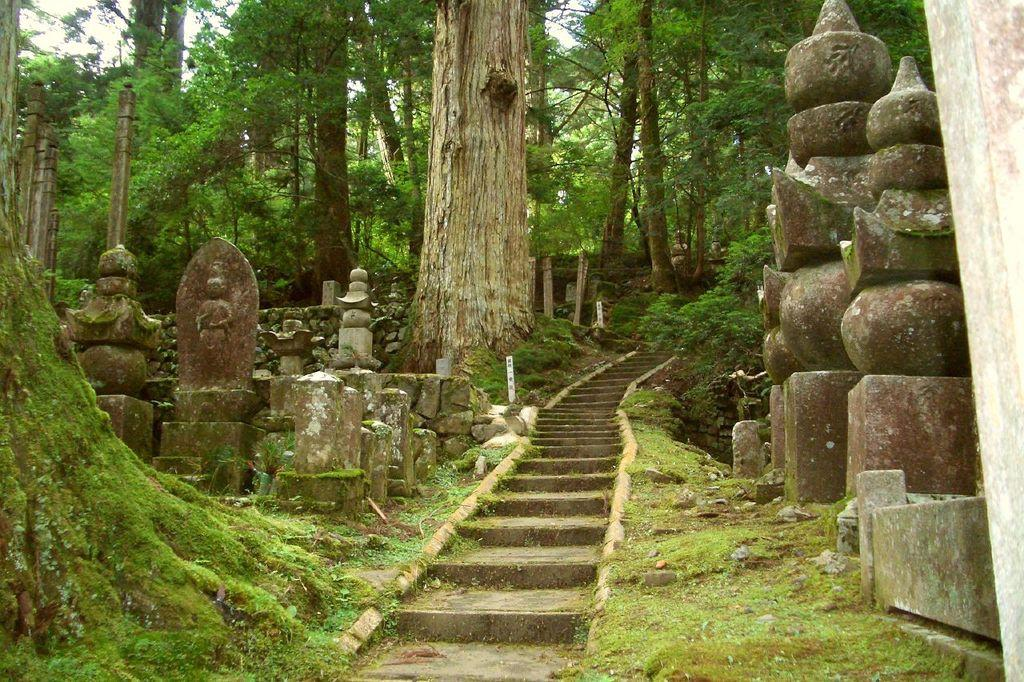What type of vegetation can be seen on the right side of the image? There are trees and grass on the right side of the image. What type of objects are present on the right side of the image? There are sculptures on the right side of the image. What can be seen in the center of the image? There are trees and a staircase in the center of the image. What type of objects are present on the left side of the image? There are sculptures on the left side of the image. What type of vegetation can be seen on the left side of the image? There are trees and grass on the left side of the image. What type of cabbage is being used as a decoration on the staircase in the image? There is no cabbage present in the image, and therefore no such decoration can be observed. 